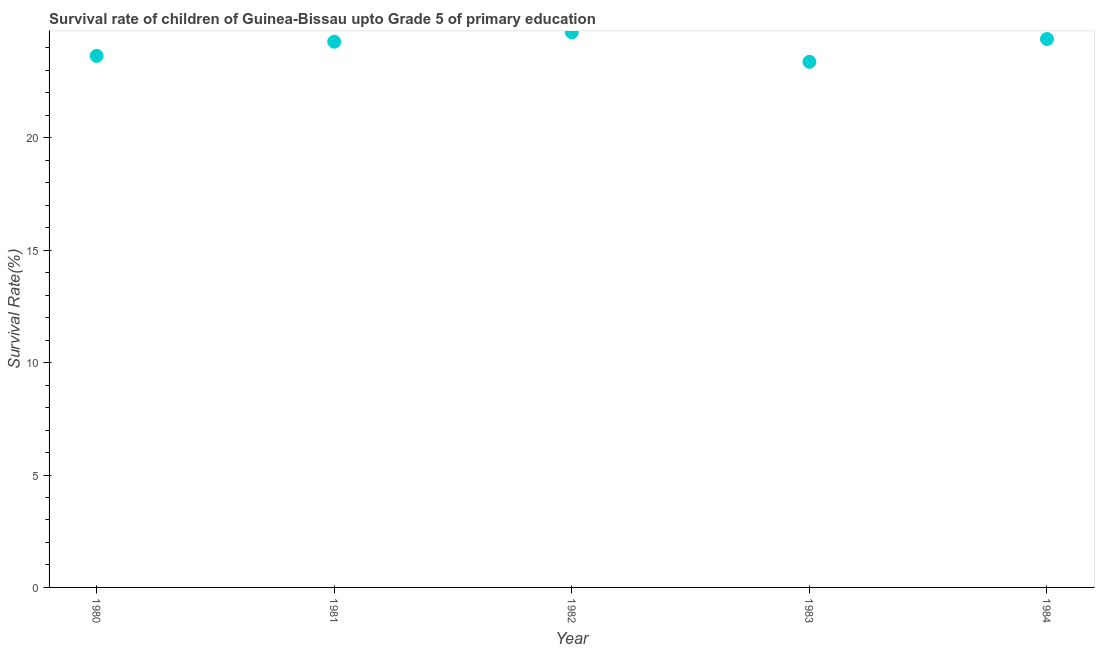What is the survival rate in 1980?
Provide a short and direct response. 23.64. Across all years, what is the maximum survival rate?
Make the answer very short. 24.69. Across all years, what is the minimum survival rate?
Your answer should be compact. 23.38. In which year was the survival rate minimum?
Ensure brevity in your answer.  1983. What is the sum of the survival rate?
Your response must be concise. 120.39. What is the difference between the survival rate in 1981 and 1982?
Your answer should be compact. -0.42. What is the average survival rate per year?
Provide a short and direct response. 24.08. What is the median survival rate?
Provide a short and direct response. 24.28. In how many years, is the survival rate greater than 7 %?
Give a very brief answer. 5. What is the ratio of the survival rate in 1980 to that in 1984?
Keep it short and to the point. 0.97. What is the difference between the highest and the second highest survival rate?
Provide a short and direct response. 0.3. Is the sum of the survival rate in 1980 and 1984 greater than the maximum survival rate across all years?
Keep it short and to the point. Yes. What is the difference between the highest and the lowest survival rate?
Your answer should be compact. 1.31. In how many years, is the survival rate greater than the average survival rate taken over all years?
Your response must be concise. 3. How many dotlines are there?
Your answer should be very brief. 1. What is the difference between two consecutive major ticks on the Y-axis?
Offer a terse response. 5. Are the values on the major ticks of Y-axis written in scientific E-notation?
Keep it short and to the point. No. Does the graph contain any zero values?
Offer a terse response. No. What is the title of the graph?
Provide a short and direct response. Survival rate of children of Guinea-Bissau upto Grade 5 of primary education. What is the label or title of the X-axis?
Give a very brief answer. Year. What is the label or title of the Y-axis?
Give a very brief answer. Survival Rate(%). What is the Survival Rate(%) in 1980?
Your answer should be very brief. 23.64. What is the Survival Rate(%) in 1981?
Make the answer very short. 24.28. What is the Survival Rate(%) in 1982?
Keep it short and to the point. 24.69. What is the Survival Rate(%) in 1983?
Provide a succinct answer. 23.38. What is the Survival Rate(%) in 1984?
Provide a succinct answer. 24.4. What is the difference between the Survival Rate(%) in 1980 and 1981?
Offer a terse response. -0.63. What is the difference between the Survival Rate(%) in 1980 and 1982?
Provide a short and direct response. -1.05. What is the difference between the Survival Rate(%) in 1980 and 1983?
Provide a short and direct response. 0.26. What is the difference between the Survival Rate(%) in 1980 and 1984?
Offer a terse response. -0.75. What is the difference between the Survival Rate(%) in 1981 and 1982?
Keep it short and to the point. -0.42. What is the difference between the Survival Rate(%) in 1981 and 1983?
Offer a very short reply. 0.89. What is the difference between the Survival Rate(%) in 1981 and 1984?
Provide a short and direct response. -0.12. What is the difference between the Survival Rate(%) in 1982 and 1983?
Offer a terse response. 1.31. What is the difference between the Survival Rate(%) in 1982 and 1984?
Give a very brief answer. 0.3. What is the difference between the Survival Rate(%) in 1983 and 1984?
Provide a short and direct response. -1.01. What is the ratio of the Survival Rate(%) in 1980 to that in 1981?
Your answer should be compact. 0.97. What is the ratio of the Survival Rate(%) in 1980 to that in 1983?
Provide a short and direct response. 1.01. What is the ratio of the Survival Rate(%) in 1980 to that in 1984?
Make the answer very short. 0.97. What is the ratio of the Survival Rate(%) in 1981 to that in 1982?
Your response must be concise. 0.98. What is the ratio of the Survival Rate(%) in 1981 to that in 1983?
Make the answer very short. 1.04. What is the ratio of the Survival Rate(%) in 1982 to that in 1983?
Provide a short and direct response. 1.06. What is the ratio of the Survival Rate(%) in 1982 to that in 1984?
Provide a succinct answer. 1.01. What is the ratio of the Survival Rate(%) in 1983 to that in 1984?
Your answer should be compact. 0.96. 